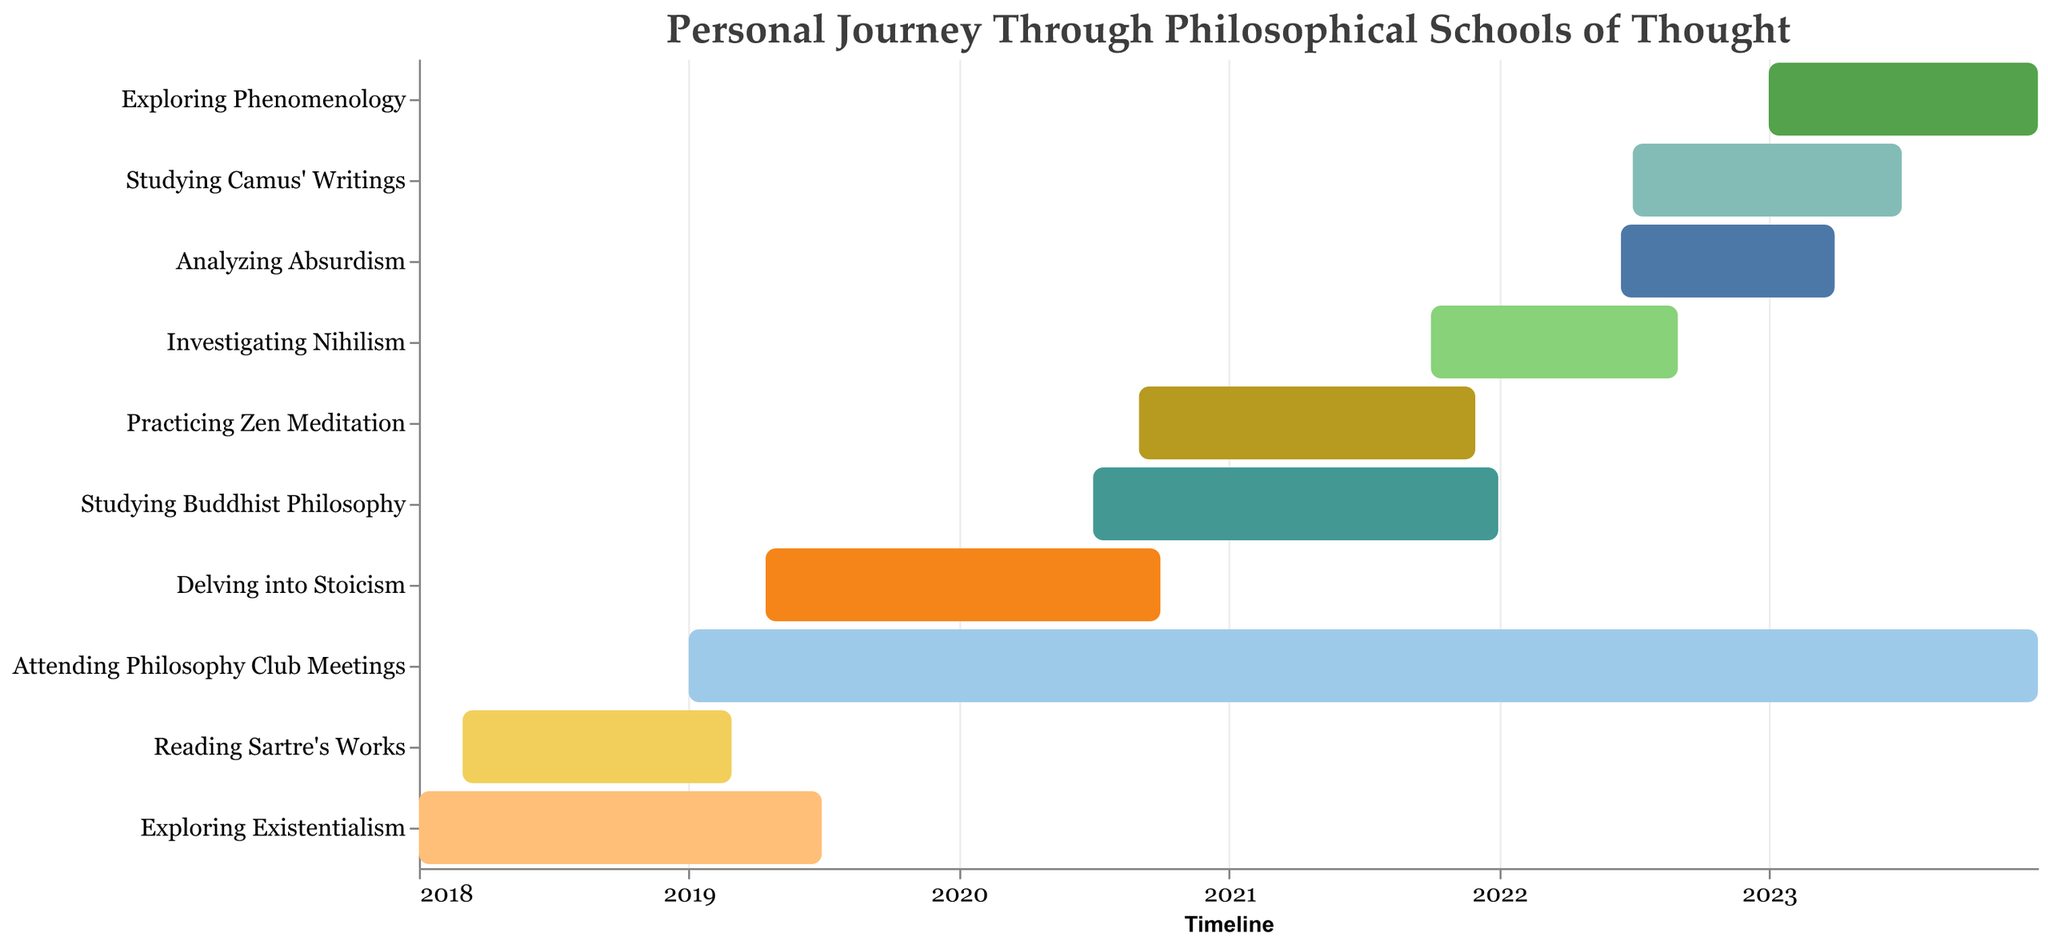what is the timeframe for studying Camus' Writings? The task "Studying Camus' Writings" starts in July 2022 and ends in June 2023.
Answer: July 2022 to June 2023 Which task overlaps with exploring Existentialism and for how long? The task "Exploring Existentialism" spans from January 2018 to June 2019. "Reading Sartre's Works" overlaps with it, from March 2018 to February 2019. The overlap duration is from March 2018 to February 2019.
Answer: "Reading Sartre's Works" for 11 months How many tasks span the year 2020? The year 2020 has four tasks overlapping it: "Delving into Stoicism", "Studying Buddhist Philosophy", "Practicing Zen Meditation", and "Attending Philosophy Club Meetings."
Answer: Four tasks What is the duration of the task "Investigating Nihilism"? "Investigating Nihilism" starts in October 2021 and ends in August 2022.
Answer: 11 months Which task has the longest duration? "Attending Philosophy Club Meetings" starts in January 2019 and ends in December 2023, making it the longest task in the chart.
Answer: Attending Philosophy Club Meetings What is the common overlapping timeframe for "Analyzing Absurdism" and "Studying Camus' Writings"? "Analyzing Absurdism" runs from June 2022 to March 2023, and "Studying Camus' Writings" runs from July 2022 to June 2023. The common overlapping timeframe is July 2022 to March 2023.
Answer: July 2022 to March 2023 What tasks are conducted simultaneously with "Studying Buddhist Philosophy"? "Studying Buddhist Philosophy" spans from July 2020 to December 2021. The overlapping tasks in this period are "Practicing Zen Meditation" and "Attending Philosophy Club Meetings."
Answer: "Practicing Zen Meditation" and "Attending Philosophy Club Meetings" How long is the overlapping period of "Practicing Zen Meditation" and "Studying Buddhist Philosophy"? "Practicing Zen Meditation" starts in September 2020 and ends in November 2021. "Studying Buddhist Philosophy" runs from July 2020 to December 2021. The overlapping period is from September 2020 to November 2021.
Answer: 15 months Which tasks finish by the end of 2019? "Exploring Existentialism" and "Reading Sartre's Works" both finish by the end of 2019.
Answer: "Exploring Existentialism" and "Reading Sartre's Works" 